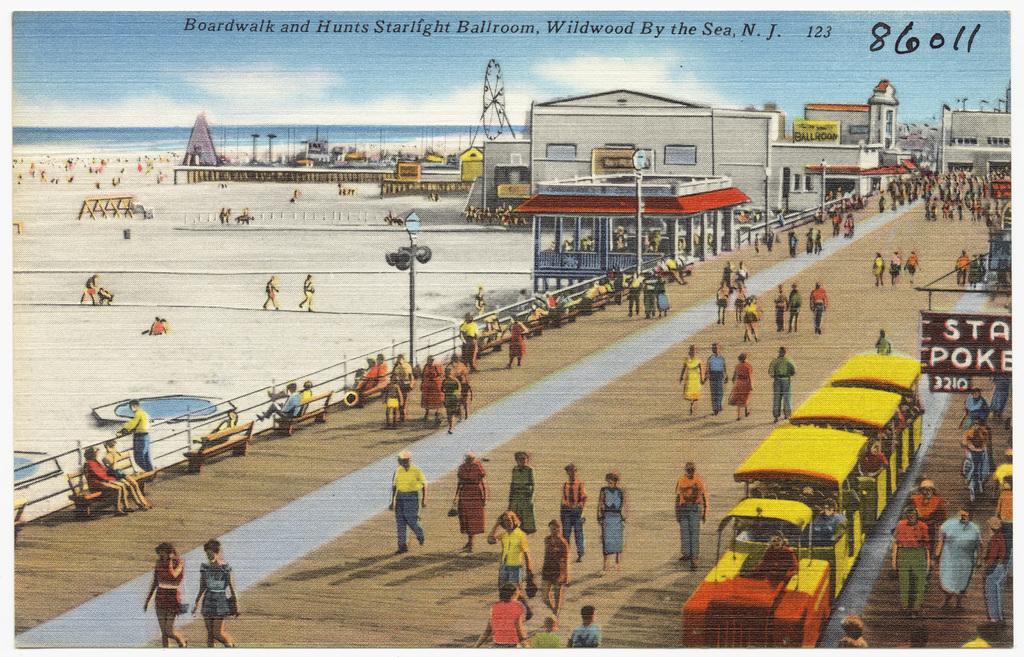What location is depicted?
Make the answer very short. New jersey. What numbers are handwritten?
Your answer should be compact. 86011. 